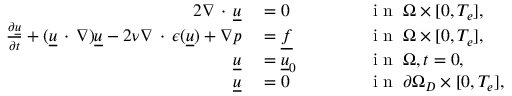<formula> <loc_0><loc_0><loc_500><loc_500>\begin{array} { r l r l } { { 2 } \nabla \, \cdot \, \underline { u } } & = 0 } & \quad i n \, \Omega \times [ 0 , T _ { e } ] , } \\ { \frac { \partial \underline { u } } { \partial t } + ( \underline { u } \, \cdot \, \nabla ) \underline { u } - 2 \nu \nabla \, \cdot \, \epsilon ( \underline { u } ) + \nabla p } & = \underline { f } } & \quad i n \, \Omega \times [ 0 , T _ { e } ] , } \\ { \underline { u } } & = \underline { u } _ { 0 } } & \quad i n \, \Omega , t = 0 , } \\ { \underline { u } } & = 0 } & \quad i n \, \partial \Omega _ { D } \times [ 0 , T _ { e } ] , } \end{array}</formula> 